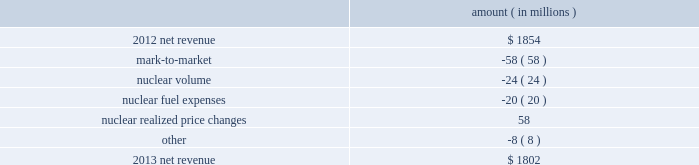The grand gulf recovery variance is primarily due to increased recovery of higher costs resulting from the grand gulf uprate .
The volume/weather variance is primarily due to the effects of more favorable weather on residential sales and an increase in industrial sales primarily due to growth in the refining segment .
The fuel recovery variance is primarily due to : 2022 the deferral of increased capacity costs that will be recovered through fuel adjustment clauses ; 2022 the expiration of the evangeline gas contract on january 1 , 2013 ; and 2022 an adjustment to deferred fuel costs recorded in the third quarter 2012 in accordance with a rate order from the puct issued in september 2012 .
See note 2 to the financial statements for further discussion of this puct order issued in entergy texas's 2011 rate case .
The miso deferral variance is primarily due to the deferral in april 2013 , as approved by the apsc , of costs incurred since march 2010 related to the transition and implementation of joining the miso rto .
The decommissioning trusts variance is primarily due to lower regulatory credits resulting from higher realized income on decommissioning trust fund investments .
There is no effect on net income as the credits are offset by interest and investment income .
Entergy wholesale commodities following is an analysis of the change in net revenue comparing 2013 to 2012 .
Amount ( in millions ) .
As shown in the table above , net revenue for entergy wholesale commodities decreased by approximately $ 52 million in 2013 primarily due to : 2022 the effect of rising forward power prices on electricity derivative instruments that are not designated as hedges , including additional financial power sales conducted in the fourth quarter 2013 to offset the planned exercise of in-the-money protective call options and to lock in margins .
These additional sales did not qualify for hedge accounting treatment , and increases in forward prices after those sales were made accounted for the majority of the negative mark-to-market variance .
It is expected that the underlying transactions will result in earnings in first quarter 2014 as these positions settle .
See note 16 to the financial statements for discussion of derivative instruments ; 2022 the decrease in net revenue compared to prior year resulting from the exercise of resupply options provided for in purchase power agreements where entergy wholesale commodities may elect to supply power from another source when the plant is not running .
Amounts related to the exercise of resupply options are included in the gwh billed in the table below ; and entergy corporation and subsidiaries management's financial discussion and analysis .
What is the growth rate in net revenue for entergy wholesale commodities in 2013? 
Computations: ((1802 - 1854) / 1854)
Answer: -0.02805. The grand gulf recovery variance is primarily due to increased recovery of higher costs resulting from the grand gulf uprate .
The volume/weather variance is primarily due to the effects of more favorable weather on residential sales and an increase in industrial sales primarily due to growth in the refining segment .
The fuel recovery variance is primarily due to : 2022 the deferral of increased capacity costs that will be recovered through fuel adjustment clauses ; 2022 the expiration of the evangeline gas contract on january 1 , 2013 ; and 2022 an adjustment to deferred fuel costs recorded in the third quarter 2012 in accordance with a rate order from the puct issued in september 2012 .
See note 2 to the financial statements for further discussion of this puct order issued in entergy texas's 2011 rate case .
The miso deferral variance is primarily due to the deferral in april 2013 , as approved by the apsc , of costs incurred since march 2010 related to the transition and implementation of joining the miso rto .
The decommissioning trusts variance is primarily due to lower regulatory credits resulting from higher realized income on decommissioning trust fund investments .
There is no effect on net income as the credits are offset by interest and investment income .
Entergy wholesale commodities following is an analysis of the change in net revenue comparing 2013 to 2012 .
Amount ( in millions ) .
As shown in the table above , net revenue for entergy wholesale commodities decreased by approximately $ 52 million in 2013 primarily due to : 2022 the effect of rising forward power prices on electricity derivative instruments that are not designated as hedges , including additional financial power sales conducted in the fourth quarter 2013 to offset the planned exercise of in-the-money protective call options and to lock in margins .
These additional sales did not qualify for hedge accounting treatment , and increases in forward prices after those sales were made accounted for the majority of the negative mark-to-market variance .
It is expected that the underlying transactions will result in earnings in first quarter 2014 as these positions settle .
See note 16 to the financial statements for discussion of derivative instruments ; 2022 the decrease in net revenue compared to prior year resulting from the exercise of resupply options provided for in purchase power agreements where entergy wholesale commodities may elect to supply power from another source when the plant is not running .
Amounts related to the exercise of resupply options are included in the gwh billed in the table below ; and entergy corporation and subsidiaries management's financial discussion and analysis .
What is the net change in net revenue for entergy wholesale commodities during 2013? 
Computations: (1802 - 1854)
Answer: -52.0. The grand gulf recovery variance is primarily due to increased recovery of higher costs resulting from the grand gulf uprate .
The volume/weather variance is primarily due to the effects of more favorable weather on residential sales and an increase in industrial sales primarily due to growth in the refining segment .
The fuel recovery variance is primarily due to : 2022 the deferral of increased capacity costs that will be recovered through fuel adjustment clauses ; 2022 the expiration of the evangeline gas contract on january 1 , 2013 ; and 2022 an adjustment to deferred fuel costs recorded in the third quarter 2012 in accordance with a rate order from the puct issued in september 2012 .
See note 2 to the financial statements for further discussion of this puct order issued in entergy texas's 2011 rate case .
The miso deferral variance is primarily due to the deferral in april 2013 , as approved by the apsc , of costs incurred since march 2010 related to the transition and implementation of joining the miso rto .
The decommissioning trusts variance is primarily due to lower regulatory credits resulting from higher realized income on decommissioning trust fund investments .
There is no effect on net income as the credits are offset by interest and investment income .
Entergy wholesale commodities following is an analysis of the change in net revenue comparing 2013 to 2012 .
Amount ( in millions ) .
As shown in the table above , net revenue for entergy wholesale commodities decreased by approximately $ 52 million in 2013 primarily due to : 2022 the effect of rising forward power prices on electricity derivative instruments that are not designated as hedges , including additional financial power sales conducted in the fourth quarter 2013 to offset the planned exercise of in-the-money protective call options and to lock in margins .
These additional sales did not qualify for hedge accounting treatment , and increases in forward prices after those sales were made accounted for the majority of the negative mark-to-market variance .
It is expected that the underlying transactions will result in earnings in first quarter 2014 as these positions settle .
See note 16 to the financial statements for discussion of derivative instruments ; 2022 the decrease in net revenue compared to prior year resulting from the exercise of resupply options provided for in purchase power agreements where entergy wholesale commodities may elect to supply power from another source when the plant is not running .
Amounts related to the exercise of resupply options are included in the gwh billed in the table below ; and entergy corporation and subsidiaries management's financial discussion and analysis .
What is the mark-to-market as a percentage of the decrease in net revenue from 2012 to 2013? 
Computations: (58 / (1854 - 1802))
Answer: 1.11538. 